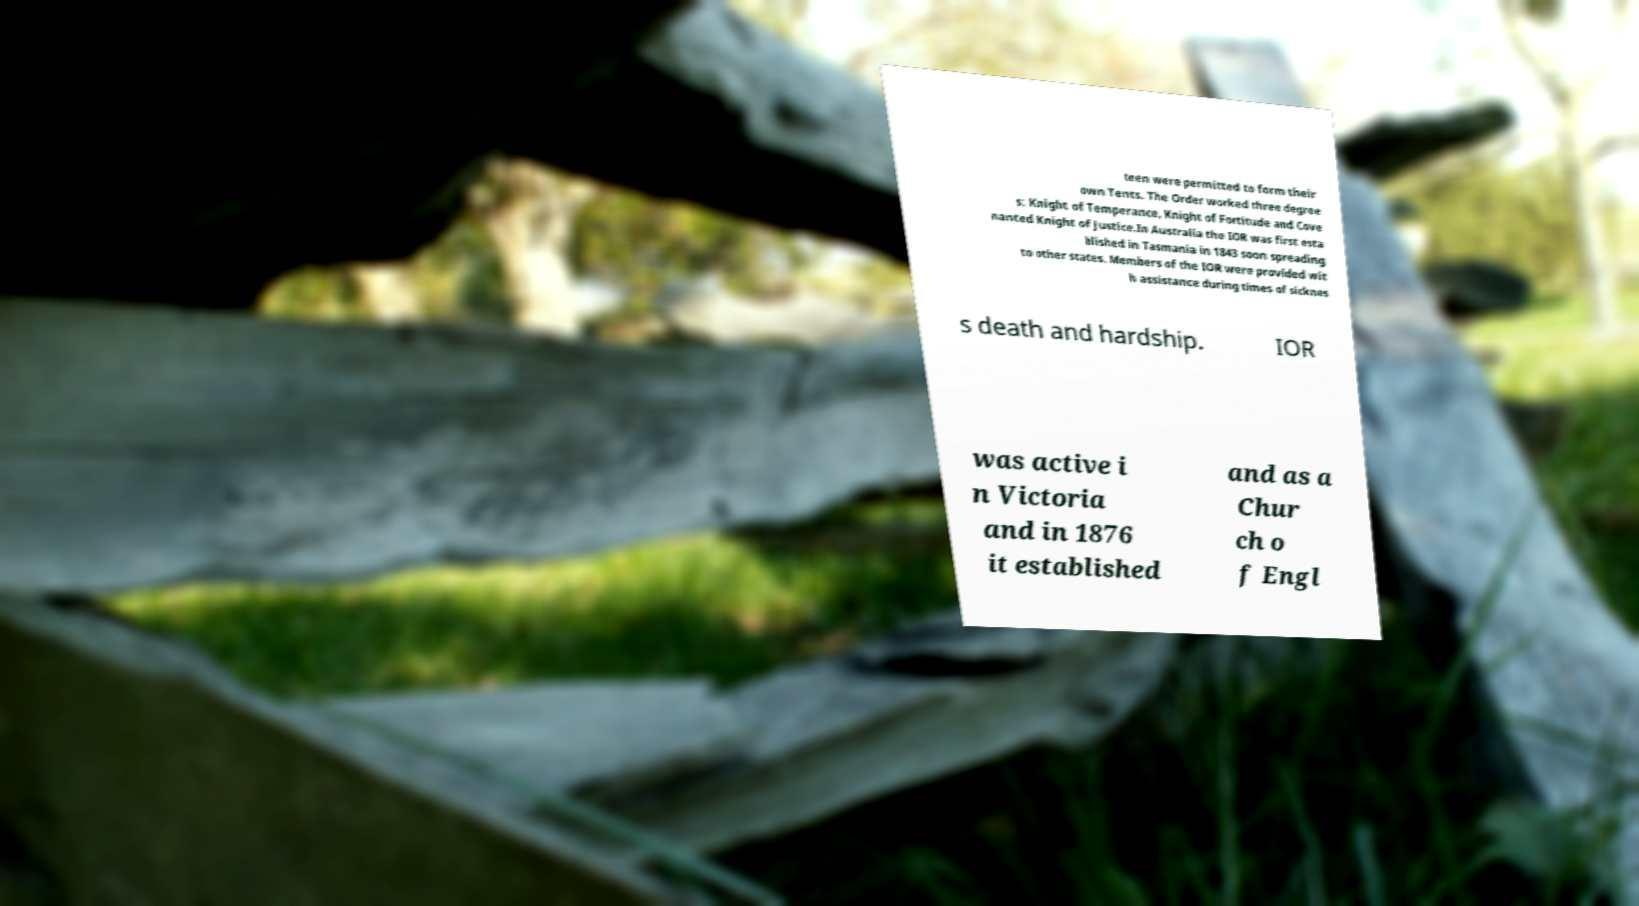Please read and relay the text visible in this image. What does it say? teen were permitted to form their own Tents. The Order worked three degree s: Knight of Temperance, Knight of Fortitude and Cove nanted Knight of Justice.In Australia the IOR was first esta blished in Tasmania in 1843 soon spreading to other states. Members of the IOR were provided wit h assistance during times of sicknes s death and hardship. IOR was active i n Victoria and in 1876 it established and as a Chur ch o f Engl 